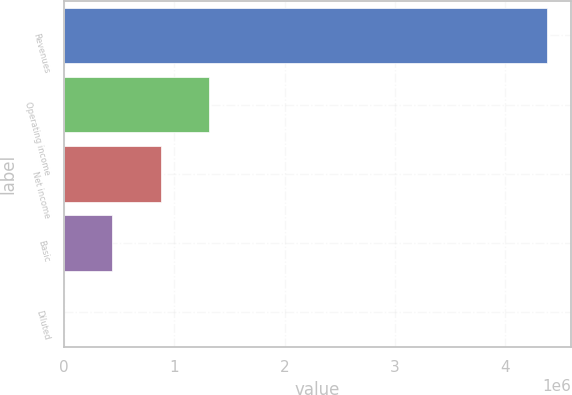Convert chart to OTSL. <chart><loc_0><loc_0><loc_500><loc_500><bar_chart><fcel>Revenues<fcel>Operating income<fcel>Net income<fcel>Basic<fcel>Diluted<nl><fcel>4.37456e+06<fcel>1.31237e+06<fcel>874913<fcel>437456<fcel>0.26<nl></chart> 